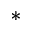Convert formula to latex. <formula><loc_0><loc_0><loc_500><loc_500>^ { * }</formula> 